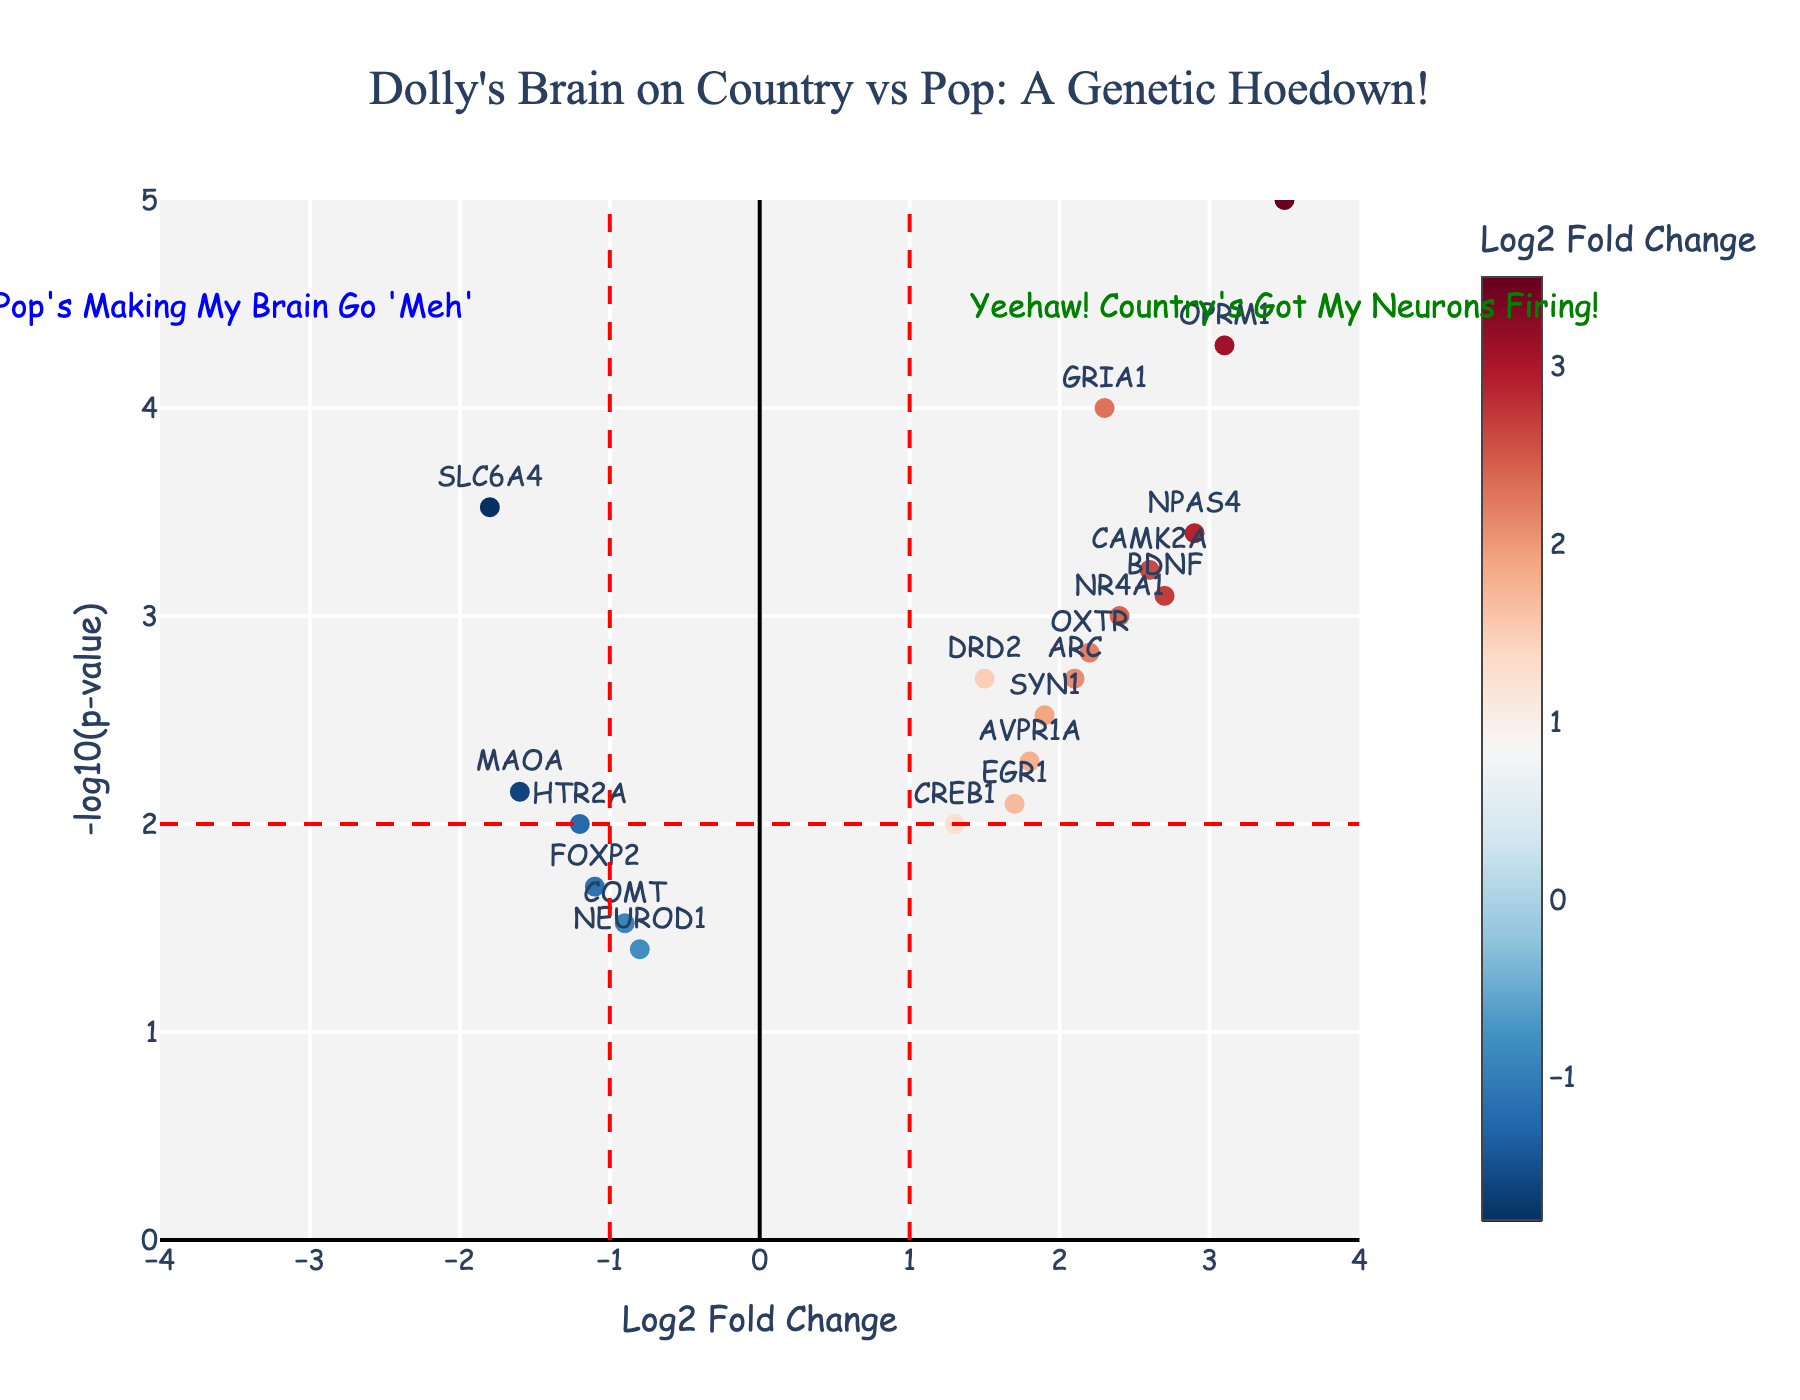What is the title of the plot? The title is typically the most prominent text at the top of the figure. Here, it reads "Dolly's Brain on Country vs Pop: A Genetic Hoedown!".
Answer: Dolly's Brain on Country vs Pop: A Genetic Hoedown! What do the x and y axes represent in the plot? The x-axis is labeled "Log2 Fold Change", representing the change in gene expression levels between the two conditions. The y-axis is labeled "-log10(p-value)", representing the statistical significance of the gene expression differences.
Answer: Log2 Fold Change and -log10(p-value) How many genes have a p-value less than 0.001? To determine this, look for points with y-values higher than 3 on the y-axis, which corresponds to -log10(0.001).
Answer: 6 Which gene shows the highest log2 fold change? Look for the point farthest to the right on the x-axis. The gene label for this point is "FOS".
Answer: FOS Which genes have a log2 fold change greater than 2 and a p-value less than 0.001? Identify points located to the right of 2 on the x-axis and above 3 on the y-axis. These genes are GRIA1, OPRM1, BDNF, FOS, NPAS4, and CAMK2A.
Answer: GRIA1, OPRM1, BDNF, FOS, NPAS4, CAMK2A What does the dashed red vertical line at x = -1 signify? This line separates genes with a log2 fold change of less than -1 from those with fold changes closer to zero or positive. It indicates a threshold for significance in the decrease of gene expression.
Answer: Threshold for fold change decrease Which gene with negative log2 fold change has the highest significance? Look for the point farthest left on the x-axis with the highest y-axis value. This gene is SLC6A4.
Answer: SLC6A4 What can be inferred about the gene NR4A1 based on its position in the plot? NR4A1 is located at approximately (2.4, 3) indicating a positive log2 fold change of 2.4 and a p-value less than 0.001 (-log10(p-value) ~ 3). This suggests that NR4A1 is significantly upregulated.
Answer: Significantly upregulated How does the gene COMT compare to the gene CREB1 in terms of log2 fold change and p-value? COMT has a log2 fold change of -0.9 and a p-value of 0.03, while CREB1 has a log2 fold change of 1.3 and a p-value of 0.01. Although CREB1 shows greater upregulation and statistical significance compared to COMT.
Answer: CREB1 more upregulated and significant than COMT 